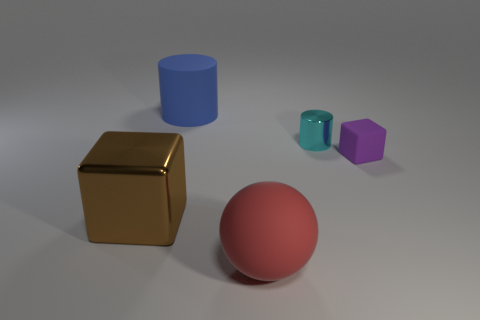What is the color of the metal object that is to the left of the shiny object to the right of the big brown object? The color of the metal object to the left of the teal, shiny cylinder and to the right of the large brown cube is gold. 